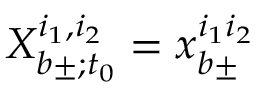Convert formula to latex. <formula><loc_0><loc_0><loc_500><loc_500>X _ { b \pm ; t _ { 0 } } ^ { i _ { 1 } , i _ { 2 } } = x _ { b \pm } ^ { i _ { 1 } i _ { 2 } }</formula> 